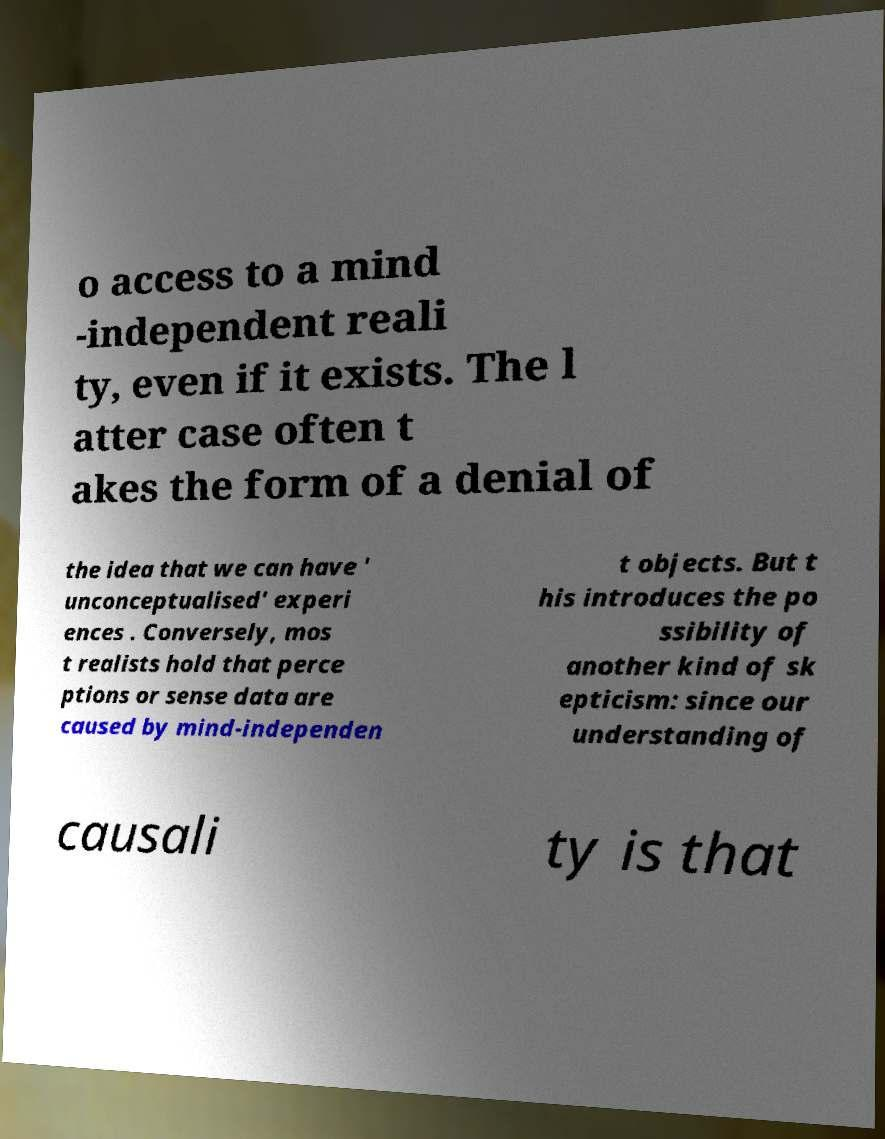Please read and relay the text visible in this image. What does it say? o access to a mind -independent reali ty, even if it exists. The l atter case often t akes the form of a denial of the idea that we can have ' unconceptualised' experi ences . Conversely, mos t realists hold that perce ptions or sense data are caused by mind-independen t objects. But t his introduces the po ssibility of another kind of sk epticism: since our understanding of causali ty is that 